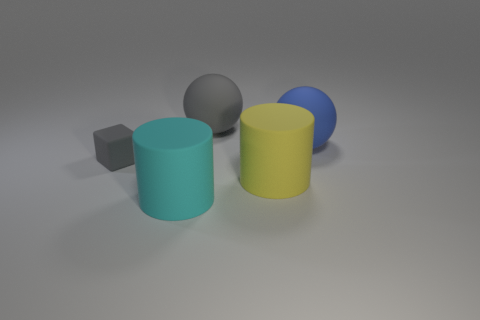What is the shape of the small gray matte object?
Your answer should be compact. Cube. Are there more cylinders that are left of the big cyan object than tiny cyan metal things?
Your answer should be very brief. No. Is there anything else that is the same shape as the yellow object?
Provide a short and direct response. Yes. There is another big thing that is the same shape as the blue object; what is its color?
Offer a terse response. Gray. What shape is the gray thing that is to the left of the large cyan cylinder?
Your answer should be very brief. Cube. Are there any big blue spheres in front of the big cyan thing?
Your answer should be compact. No. Is there any other thing that is the same size as the gray rubber cube?
Offer a terse response. No. The other tiny object that is made of the same material as the cyan object is what color?
Your response must be concise. Gray. Do the large thing that is right of the big yellow thing and the matte cylinder that is to the left of the large gray sphere have the same color?
Your answer should be compact. No. What number of cubes are either big cyan rubber objects or blue matte things?
Keep it short and to the point. 0. 